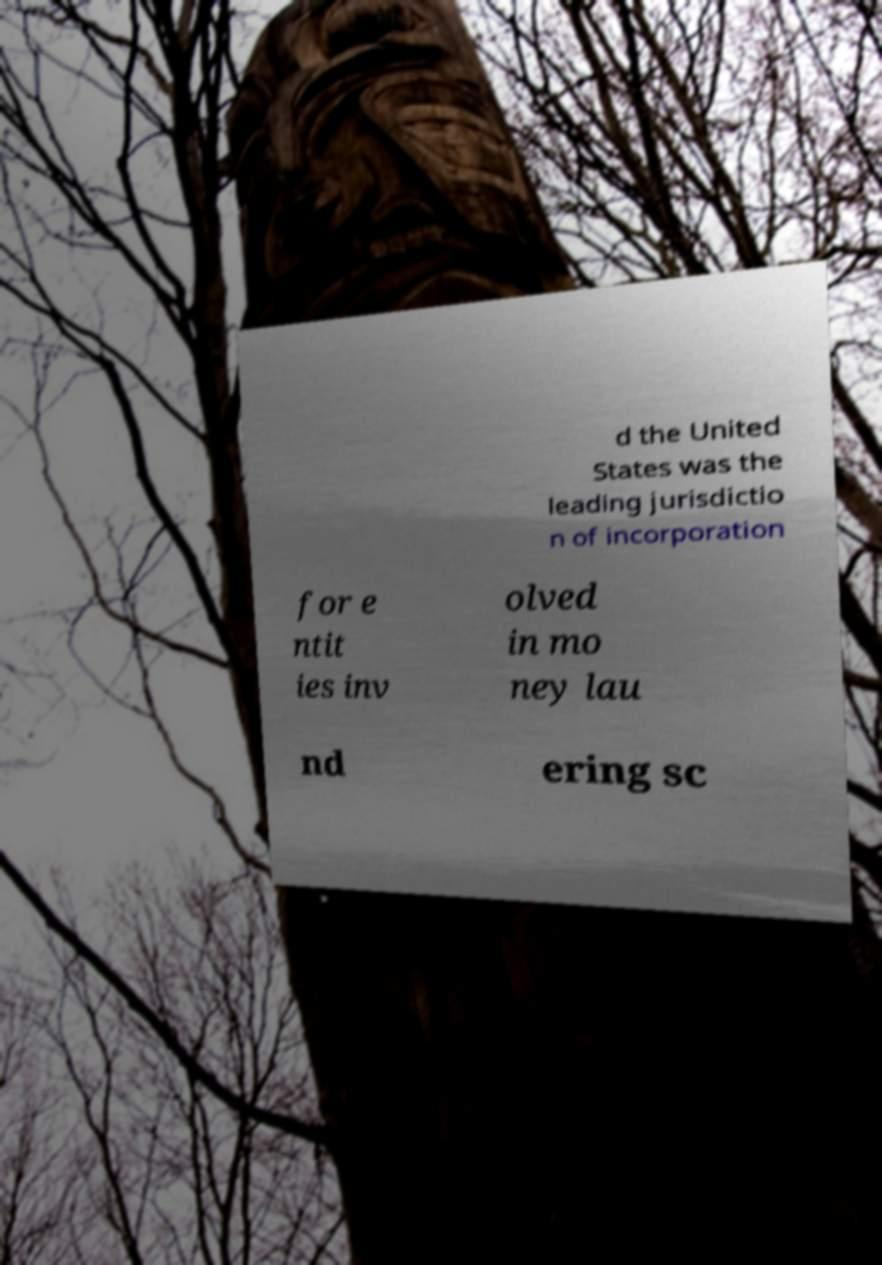There's text embedded in this image that I need extracted. Can you transcribe it verbatim? d the United States was the leading jurisdictio n of incorporation for e ntit ies inv olved in mo ney lau nd ering sc 